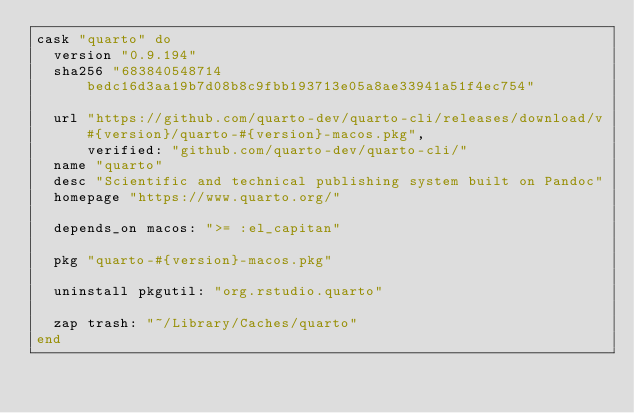<code> <loc_0><loc_0><loc_500><loc_500><_Ruby_>cask "quarto" do
  version "0.9.194"
  sha256 "683840548714bedc16d3aa19b7d08b8c9fbb193713e05a8ae33941a51f4ec754"

  url "https://github.com/quarto-dev/quarto-cli/releases/download/v#{version}/quarto-#{version}-macos.pkg",
      verified: "github.com/quarto-dev/quarto-cli/"
  name "quarto"
  desc "Scientific and technical publishing system built on Pandoc"
  homepage "https://www.quarto.org/"

  depends_on macos: ">= :el_capitan"

  pkg "quarto-#{version}-macos.pkg"

  uninstall pkgutil: "org.rstudio.quarto"

  zap trash: "~/Library/Caches/quarto"
end
</code> 